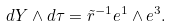<formula> <loc_0><loc_0><loc_500><loc_500>d Y \wedge d \tau = \tilde { r } ^ { - 1 } e ^ { 1 } \wedge e ^ { 3 } .</formula> 